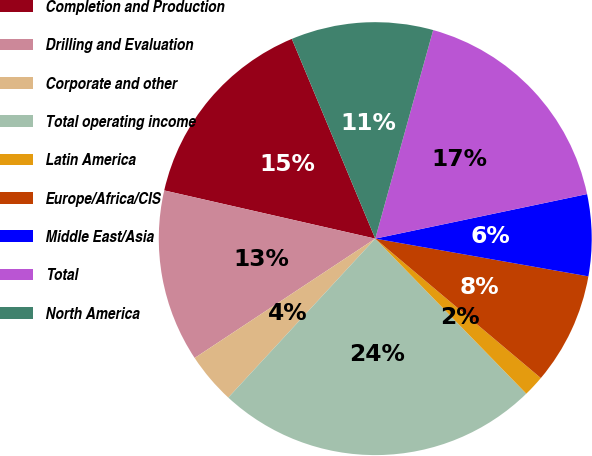Convert chart to OTSL. <chart><loc_0><loc_0><loc_500><loc_500><pie_chart><fcel>Completion and Production<fcel>Drilling and Evaluation<fcel>Corporate and other<fcel>Total operating income<fcel>Latin America<fcel>Europe/Africa/CIS<fcel>Middle East/Asia<fcel>Total<fcel>North America<nl><fcel>15.13%<fcel>12.87%<fcel>3.83%<fcel>24.17%<fcel>1.57%<fcel>8.35%<fcel>6.09%<fcel>17.39%<fcel>10.61%<nl></chart> 